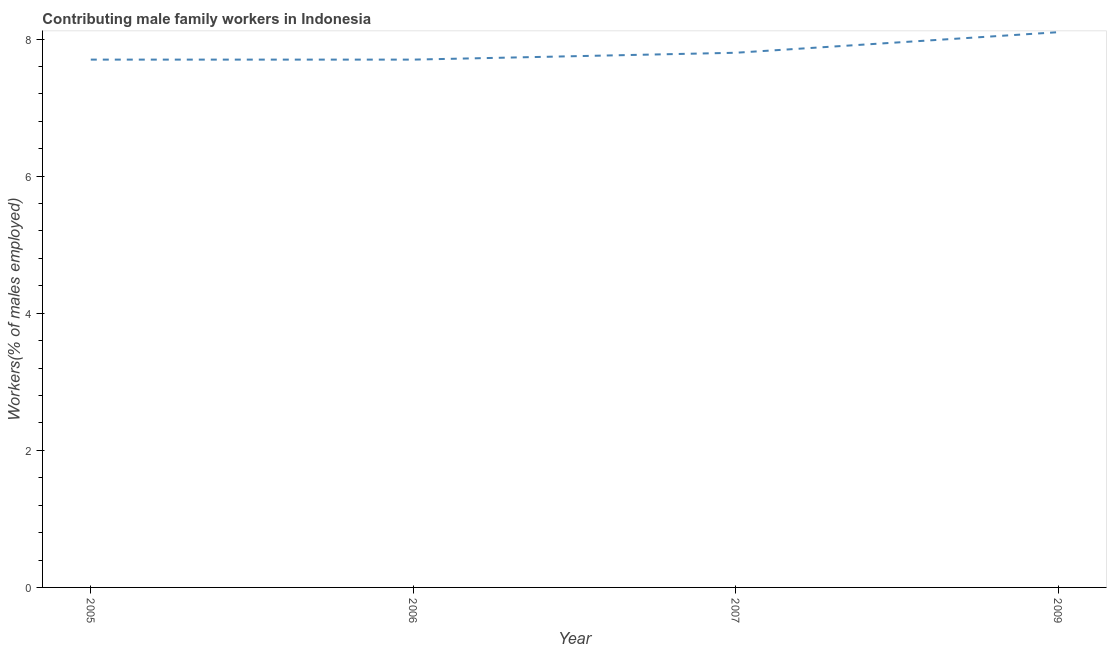What is the contributing male family workers in 2006?
Make the answer very short. 7.7. Across all years, what is the maximum contributing male family workers?
Give a very brief answer. 8.1. Across all years, what is the minimum contributing male family workers?
Your answer should be very brief. 7.7. What is the sum of the contributing male family workers?
Your answer should be compact. 31.3. What is the difference between the contributing male family workers in 2006 and 2007?
Your answer should be compact. -0.1. What is the average contributing male family workers per year?
Your response must be concise. 7.83. What is the median contributing male family workers?
Give a very brief answer. 7.75. What is the ratio of the contributing male family workers in 2005 to that in 2009?
Make the answer very short. 0.95. Is the contributing male family workers in 2007 less than that in 2009?
Provide a short and direct response. Yes. What is the difference between the highest and the second highest contributing male family workers?
Make the answer very short. 0.3. Is the sum of the contributing male family workers in 2005 and 2006 greater than the maximum contributing male family workers across all years?
Your answer should be compact. Yes. What is the difference between the highest and the lowest contributing male family workers?
Make the answer very short. 0.4. Does the contributing male family workers monotonically increase over the years?
Provide a short and direct response. No. What is the difference between two consecutive major ticks on the Y-axis?
Your response must be concise. 2. Does the graph contain any zero values?
Provide a succinct answer. No. What is the title of the graph?
Provide a short and direct response. Contributing male family workers in Indonesia. What is the label or title of the Y-axis?
Make the answer very short. Workers(% of males employed). What is the Workers(% of males employed) of 2005?
Your response must be concise. 7.7. What is the Workers(% of males employed) in 2006?
Offer a terse response. 7.7. What is the Workers(% of males employed) in 2007?
Your answer should be compact. 7.8. What is the Workers(% of males employed) in 2009?
Give a very brief answer. 8.1. What is the difference between the Workers(% of males employed) in 2005 and 2007?
Your answer should be very brief. -0.1. What is the difference between the Workers(% of males employed) in 2007 and 2009?
Provide a short and direct response. -0.3. What is the ratio of the Workers(% of males employed) in 2005 to that in 2009?
Give a very brief answer. 0.95. What is the ratio of the Workers(% of males employed) in 2006 to that in 2009?
Make the answer very short. 0.95. 